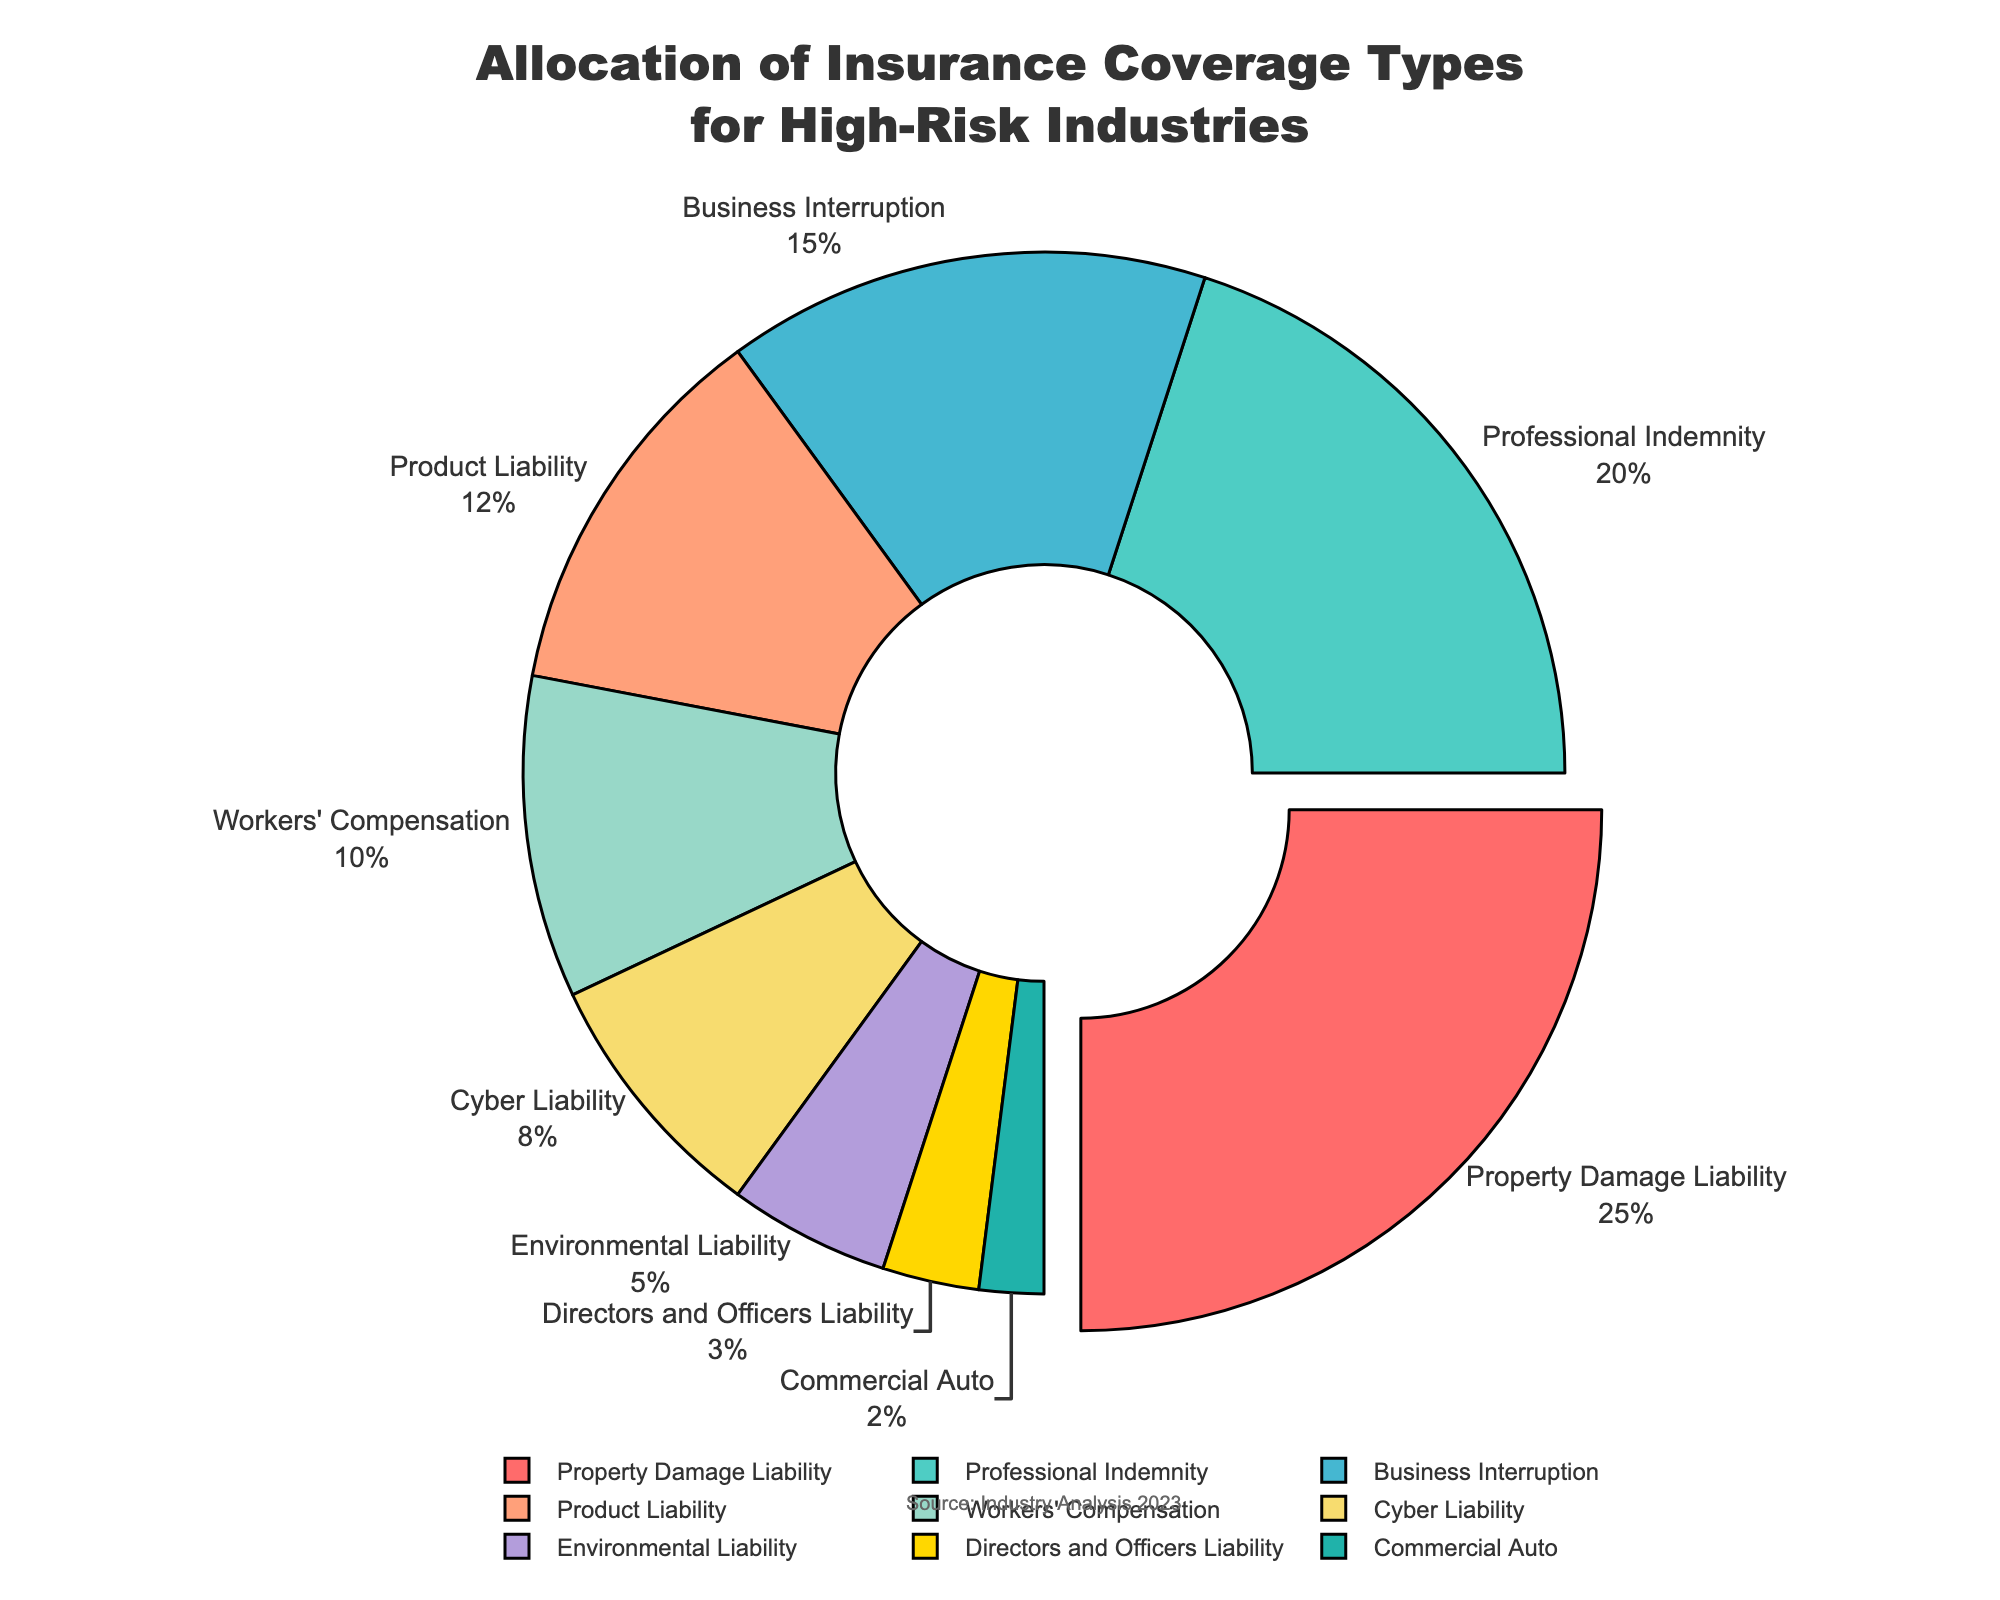Which insurance type has the highest allocation percentage? The chart shows the allocation percentages for different insurance types. The segment with the highest percentage is "Property Damage Liability" at 25%.
Answer: Property Damage Liability What is the combined percentage of Professional Indemnity and Cyber Liability? To find the combined percentage, add the percentages of Professional Indemnity (20%) and Cyber Liability (8%), which results in 20 + 8 = 28%.
Answer: 28% How much higher is the percentage of Business Interruption compared to Environmental Liability? The percentage for Business Interruption is 15%, and for Environmental Liability, it is 5%. The difference is 15 - 5 = 10%.
Answer: 10% Which insurance type has the smallest allocation? The segment with the smallest percentage is "Commercial Auto" at 2%.
Answer: Commercial Auto Compare the percentages of Product Liability and Workers' Compensation. Which one is higher and by how much? Product Liability has a percentage of 12%, while Workers' Compensation has 10%. Therefore, Product Liability is higher by 12 - 10 = 2%.
Answer: Product Liability by 2% What is the total percentage allocated to Property Damage Liability and Product Liability combined? Sum the percentages for Property Damage Liability (25%) and Product Liability (12%) to get 25 + 12 = 37%.
Answer: 37% What colors represent Property Damage Liability and Professional Indemnity in the chart? In the chart, Property Damage Liability is represented by red, and Professional Indemnity by teal.
Answer: Red and Teal What is the difference in percentage between Professional Indemnity and Cyber Liability? The percentage for Professional Indemnity is 20%, and for Cyber Liability, it is 8%. The difference is 20 - 8 = 12%.
Answer: 12% Which insurance type has a slightly higher allocation than Cyber Liability and by how much? Workers' Compensation has a percentage of 10%, which is slightly higher than Cyber Liability's 8%. The difference is 10 - 8 = 2%.
Answer: Workers' Compensation by 2% What is the sum of the percentages for the insurance types that make up more than 10% each? The insurance types with more than 10% are Property Damage Liability (25%), Professional Indemnity (20%), Business Interruption (15%), and Product Liability (12%). The sum is 25 + 20 + 15 + 12 = 72%.
Answer: 72% 